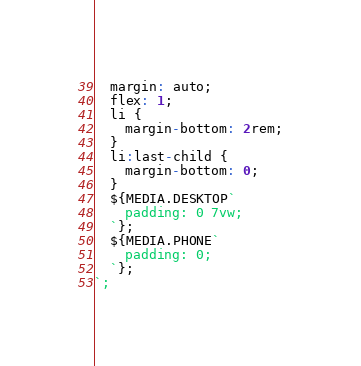Convert code to text. <code><loc_0><loc_0><loc_500><loc_500><_JavaScript_>  margin: auto;
  flex: 1;
  li {
    margin-bottom: 2rem;
  }
  li:last-child {
    margin-bottom: 0;
  }
  ${MEDIA.DESKTOP`
    padding: 0 7vw;
  `};
  ${MEDIA.PHONE`
    padding: 0;
  `};
`;
</code> 